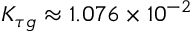Convert formula to latex. <formula><loc_0><loc_0><loc_500><loc_500>K _ { \tau g } \approx 1 . 0 7 6 \times 1 0 ^ { - 2 }</formula> 